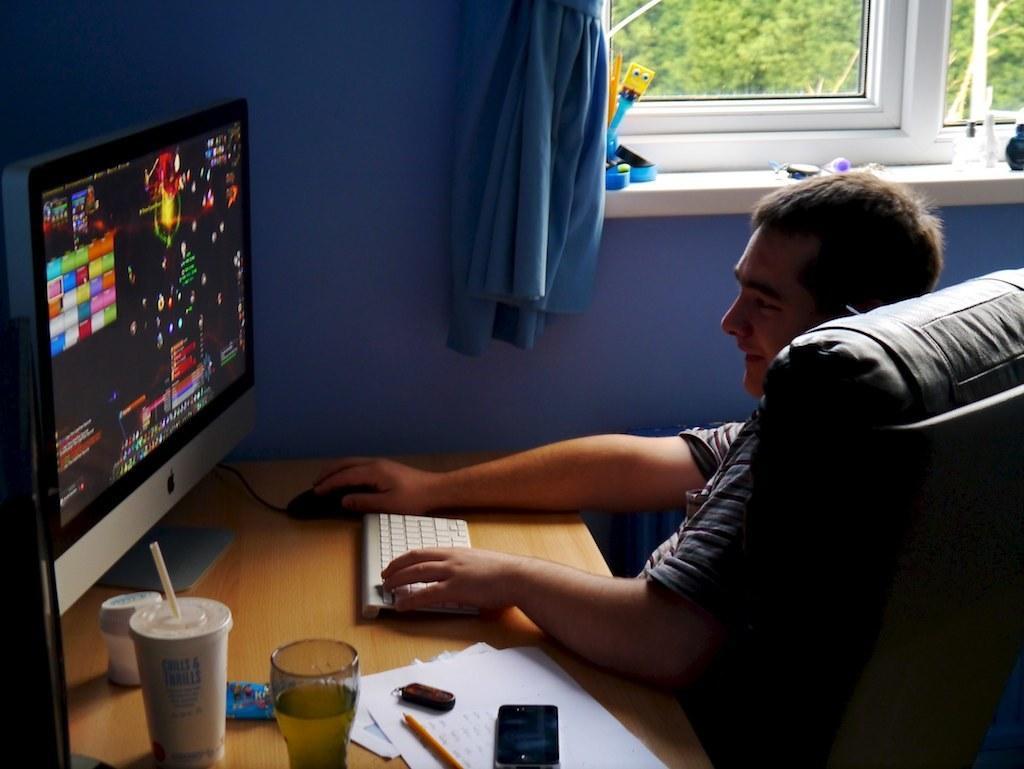Please provide a concise description of this image. In this image there is a man who is sitting in the chair and playing the game in the computer. There is a table in front of him on which there is key board,cup,glass,paper and pen. Beside the man there is wall,window and the curtain. 